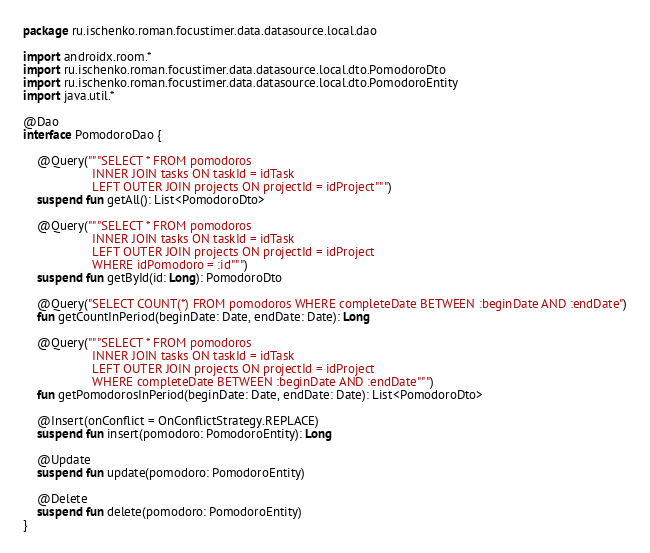<code> <loc_0><loc_0><loc_500><loc_500><_Kotlin_>package ru.ischenko.roman.focustimer.data.datasource.local.dao

import androidx.room.*
import ru.ischenko.roman.focustimer.data.datasource.local.dto.PomodoroDto
import ru.ischenko.roman.focustimer.data.datasource.local.dto.PomodoroEntity
import java.util.*

@Dao
interface PomodoroDao {

    @Query("""SELECT * FROM pomodoros
                    INNER JOIN tasks ON taskId = idTask
                    LEFT OUTER JOIN projects ON projectId = idProject""")
    suspend fun getAll(): List<PomodoroDto>

    @Query("""SELECT * FROM pomodoros
                    INNER JOIN tasks ON taskId = idTask
                    LEFT OUTER JOIN projects ON projectId = idProject
                    WHERE idPomodoro = :id""")
    suspend fun getById(id: Long): PomodoroDto

    @Query("SELECT COUNT(*) FROM pomodoros WHERE completeDate BETWEEN :beginDate AND :endDate")
    fun getCountInPeriod(beginDate: Date, endDate: Date): Long

    @Query("""SELECT * FROM pomodoros
                    INNER JOIN tasks ON taskId = idTask
                    LEFT OUTER JOIN projects ON projectId = idProject
                    WHERE completeDate BETWEEN :beginDate AND :endDate""")
    fun getPomodorosInPeriod(beginDate: Date, endDate: Date): List<PomodoroDto>

    @Insert(onConflict = OnConflictStrategy.REPLACE)
    suspend fun insert(pomodoro: PomodoroEntity): Long

    @Update
    suspend fun update(pomodoro: PomodoroEntity)

    @Delete
    suspend fun delete(pomodoro: PomodoroEntity)
}</code> 